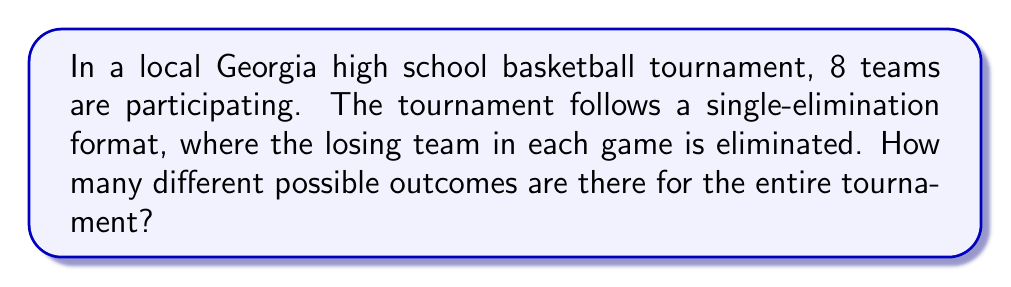Could you help me with this problem? Let's approach this step-by-step:

1) In a single-elimination tournament with 8 teams, there will be 7 games in total:
   - 4 games in the first round
   - 2 games in the semi-finals
   - 1 game in the final

2) For each game, there are 2 possible outcomes (either team can win).

3) The number of possible outcomes for the entire tournament is the product of the number of possible outcomes for each game.

4) Therefore, we can calculate the total number of possible outcomes as:

   $$2^7 = 2 \times 2 \times 2 \times 2 \times 2 \times 2 \times 2 = 128$$

5) We can also express this using exponent notation:

   $$2^7 = 128$$

This means there are 128 different possible ways the tournament could unfold, each representing a unique combination of game outcomes.

Go Georgia teams!
Answer: 128 